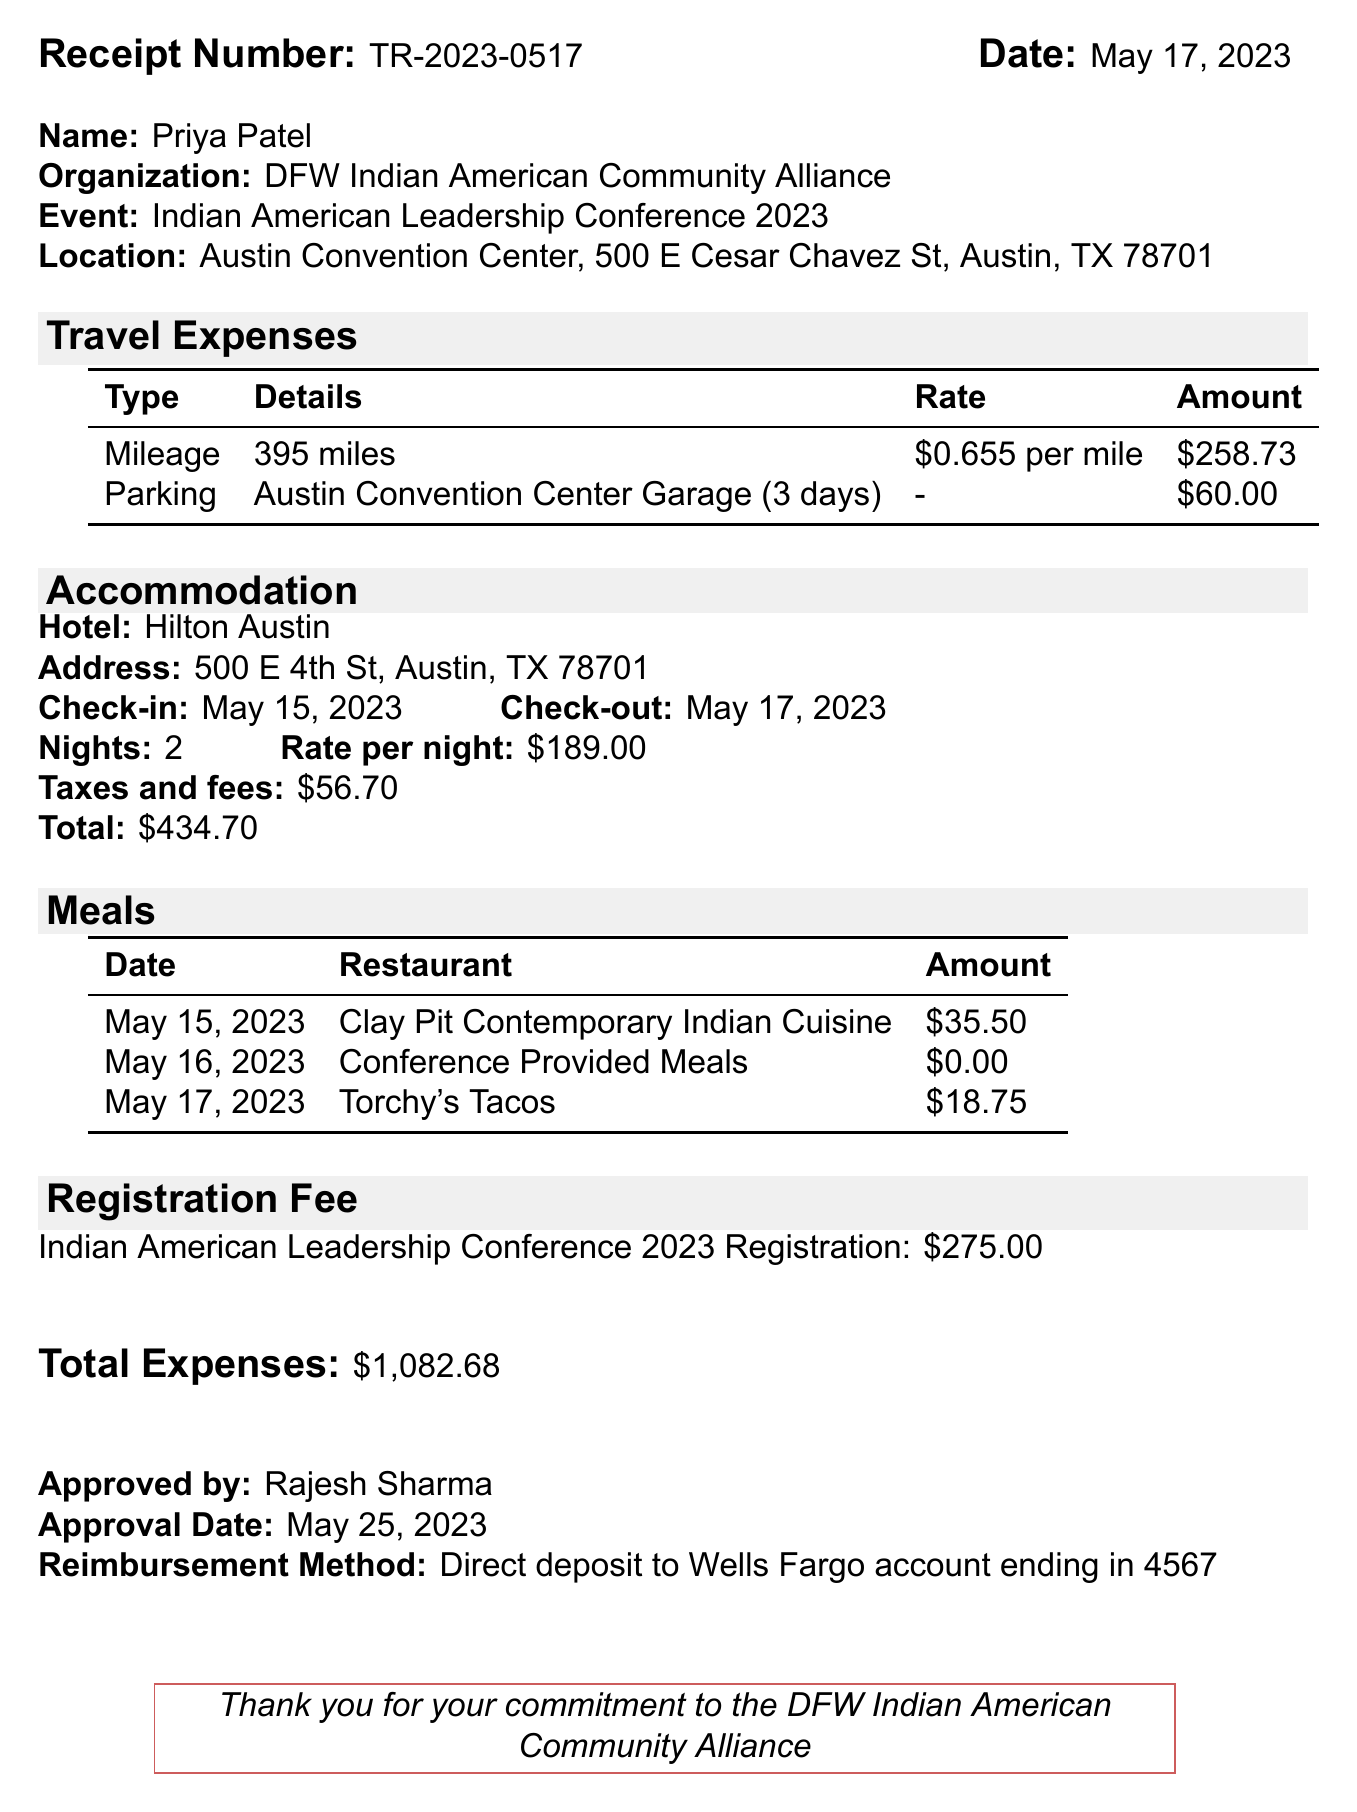What is the receipt number? The receipt number is provided at the top of the document as a unique identifier for this expense report.
Answer: TR-2023-0517 What is the total amount for hotel charges? The total amount for accommodation is detailed in the accommodation section of the document, including the hotel charges.
Answer: $434.70 How many miles were traveled? The document specifies the distance traveled for reimbursement under travel expenses as mileage.
Answer: 395 miles Who approved the expense report? The name of the person who approved the report is listed near the end of the document under the approval section.
Answer: Rajesh Sharma What was the registration fee for the conference? The registration fee is specifically mentioned in a distinct section, outlining the cost to attend the conference.
Answer: $275.00 What is the total expense amount? The document summarizes all expenses and provides a total near the end.
Answer: $1,082.68 How many nights did Priya stay at the hotel? This information is included in the accommodation section detailing the duration of the hotel stay.
Answer: 2 What date did Priya check in to the hotel? This check-in date is specified in the accommodation details section of the document.
Answer: May 15, 2023 What restaurant did Priya visit on May 15, 2023? The meal section lists the restaurant name corresponding to each date for the meals incurred.
Answer: Clay Pit Contemporary Indian Cuisine 